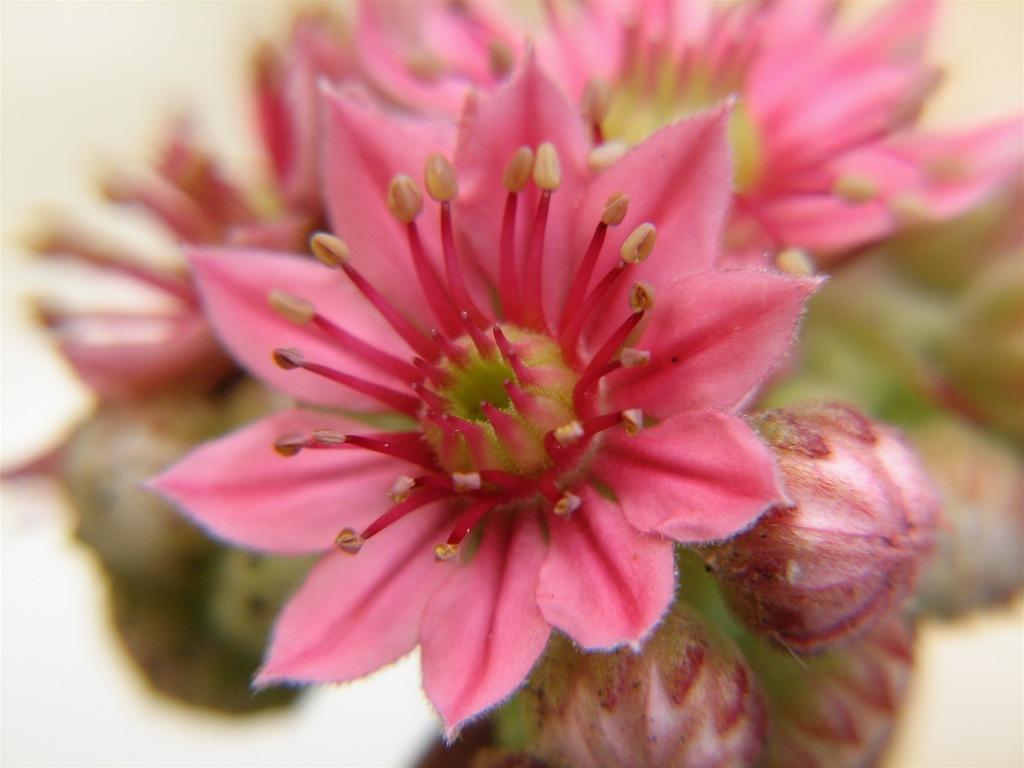What type of plants can be seen in the image? There are flowers in the image. Can you describe the stage of growth for some of the plants in the image? Yes, there are buds in the image, which are flowers in the early stages of development. What type of jail can be seen in the image? There is no jail present in the image; it features flowers and buds. 